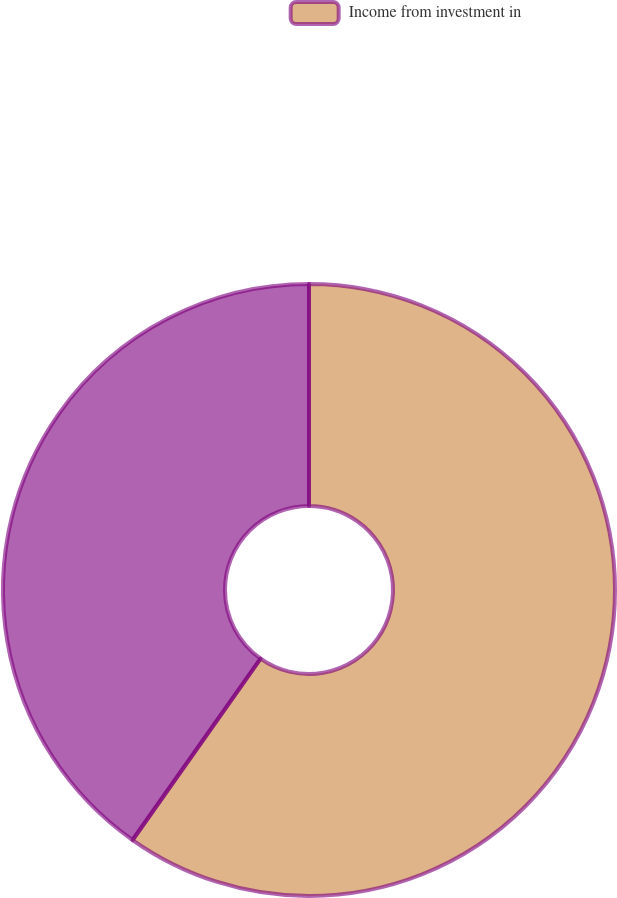Convert chart to OTSL. <chart><loc_0><loc_0><loc_500><loc_500><pie_chart><fcel>Income from investment in<fcel>Unnamed: 1<nl><fcel>59.78%<fcel>40.22%<nl></chart> 